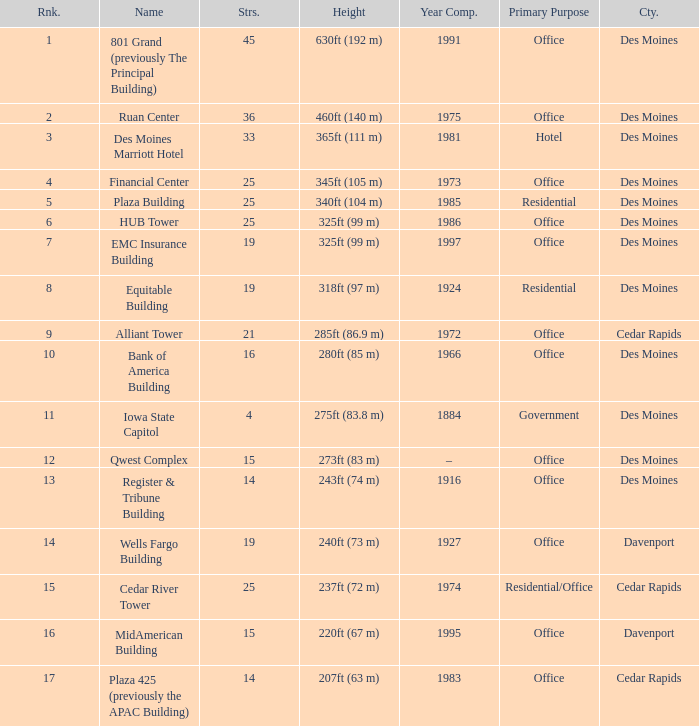Would you mind parsing the complete table? {'header': ['Rnk.', 'Name', 'Strs.', 'Height', 'Year Comp.', 'Primary Purpose', 'Cty.'], 'rows': [['1', '801 Grand (previously The Principal Building)', '45', '630ft (192 m)', '1991', 'Office', 'Des Moines'], ['2', 'Ruan Center', '36', '460ft (140 m)', '1975', 'Office', 'Des Moines'], ['3', 'Des Moines Marriott Hotel', '33', '365ft (111 m)', '1981', 'Hotel', 'Des Moines'], ['4', 'Financial Center', '25', '345ft (105 m)', '1973', 'Office', 'Des Moines'], ['5', 'Plaza Building', '25', '340ft (104 m)', '1985', 'Residential', 'Des Moines'], ['6', 'HUB Tower', '25', '325ft (99 m)', '1986', 'Office', 'Des Moines'], ['7', 'EMC Insurance Building', '19', '325ft (99 m)', '1997', 'Office', 'Des Moines'], ['8', 'Equitable Building', '19', '318ft (97 m)', '1924', 'Residential', 'Des Moines'], ['9', 'Alliant Tower', '21', '285ft (86.9 m)', '1972', 'Office', 'Cedar Rapids'], ['10', 'Bank of America Building', '16', '280ft (85 m)', '1966', 'Office', 'Des Moines'], ['11', 'Iowa State Capitol', '4', '275ft (83.8 m)', '1884', 'Government', 'Des Moines'], ['12', 'Qwest Complex', '15', '273ft (83 m)', '–', 'Office', 'Des Moines'], ['13', 'Register & Tribune Building', '14', '243ft (74 m)', '1916', 'Office', 'Des Moines'], ['14', 'Wells Fargo Building', '19', '240ft (73 m)', '1927', 'Office', 'Davenport'], ['15', 'Cedar River Tower', '25', '237ft (72 m)', '1974', 'Residential/Office', 'Cedar Rapids'], ['16', 'MidAmerican Building', '15', '220ft (67 m)', '1995', 'Office', 'Davenport'], ['17', 'Plaza 425 (previously the APAC Building)', '14', '207ft (63 m)', '1983', 'Office', 'Cedar Rapids']]} What is the height of the EMC Insurance Building in Des Moines? 325ft (99 m). 